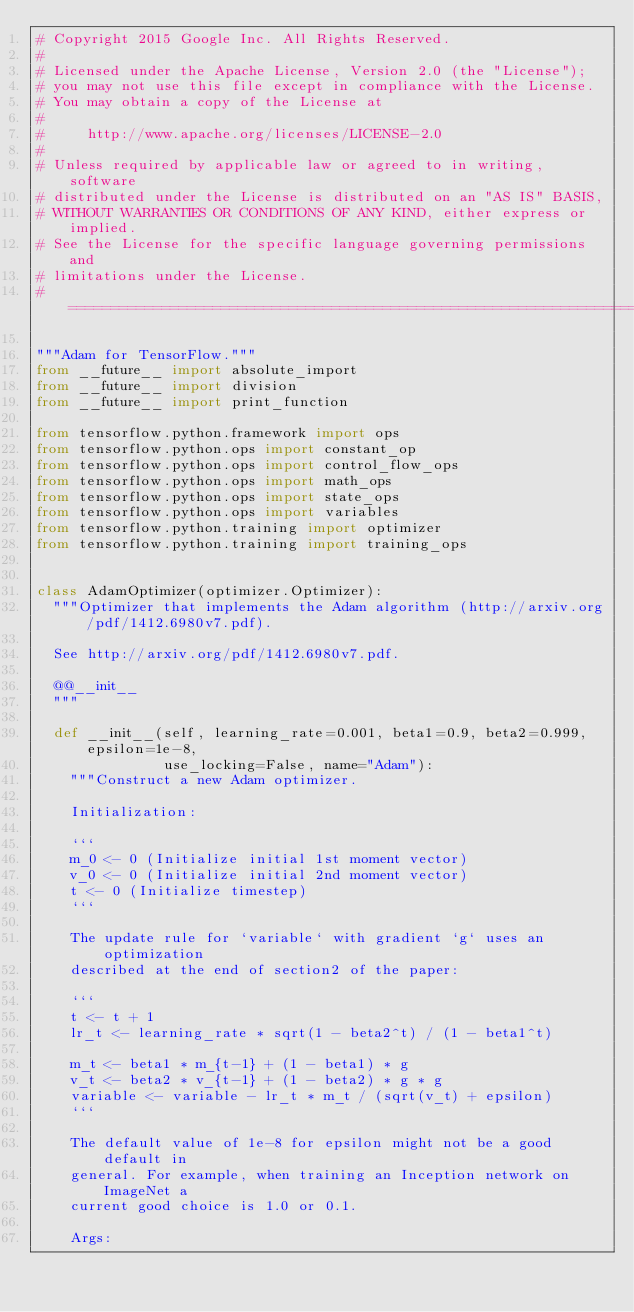<code> <loc_0><loc_0><loc_500><loc_500><_Python_># Copyright 2015 Google Inc. All Rights Reserved.
#
# Licensed under the Apache License, Version 2.0 (the "License");
# you may not use this file except in compliance with the License.
# You may obtain a copy of the License at
#
#     http://www.apache.org/licenses/LICENSE-2.0
#
# Unless required by applicable law or agreed to in writing, software
# distributed under the License is distributed on an "AS IS" BASIS,
# WITHOUT WARRANTIES OR CONDITIONS OF ANY KIND, either express or implied.
# See the License for the specific language governing permissions and
# limitations under the License.
# ==============================================================================

"""Adam for TensorFlow."""
from __future__ import absolute_import
from __future__ import division
from __future__ import print_function

from tensorflow.python.framework import ops
from tensorflow.python.ops import constant_op
from tensorflow.python.ops import control_flow_ops
from tensorflow.python.ops import math_ops
from tensorflow.python.ops import state_ops
from tensorflow.python.ops import variables
from tensorflow.python.training import optimizer
from tensorflow.python.training import training_ops


class AdamOptimizer(optimizer.Optimizer):
  """Optimizer that implements the Adam algorithm (http://arxiv.org/pdf/1412.6980v7.pdf).

  See http://arxiv.org/pdf/1412.6980v7.pdf.

  @@__init__
  """

  def __init__(self, learning_rate=0.001, beta1=0.9, beta2=0.999, epsilon=1e-8,
               use_locking=False, name="Adam"):
    """Construct a new Adam optimizer.

    Initialization:

    ```
    m_0 <- 0 (Initialize initial 1st moment vector)
    v_0 <- 0 (Initialize initial 2nd moment vector)
    t <- 0 (Initialize timestep)
    ```

    The update rule for `variable` with gradient `g` uses an optimization
    described at the end of section2 of the paper:

    ```
    t <- t + 1
    lr_t <- learning_rate * sqrt(1 - beta2^t) / (1 - beta1^t)

    m_t <- beta1 * m_{t-1} + (1 - beta1) * g
    v_t <- beta2 * v_{t-1} + (1 - beta2) * g * g
    variable <- variable - lr_t * m_t / (sqrt(v_t) + epsilon)
    ```

    The default value of 1e-8 for epsilon might not be a good default in
    general. For example, when training an Inception network on ImageNet a
    current good choice is 1.0 or 0.1.

    Args:</code> 